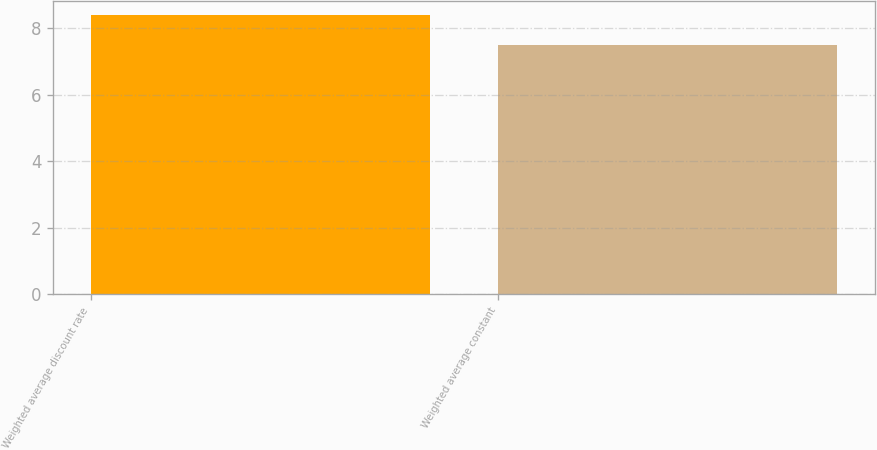Convert chart. <chart><loc_0><loc_0><loc_500><loc_500><bar_chart><fcel>Weighted average discount rate<fcel>Weighted average constant<nl><fcel>8.4<fcel>7.5<nl></chart> 